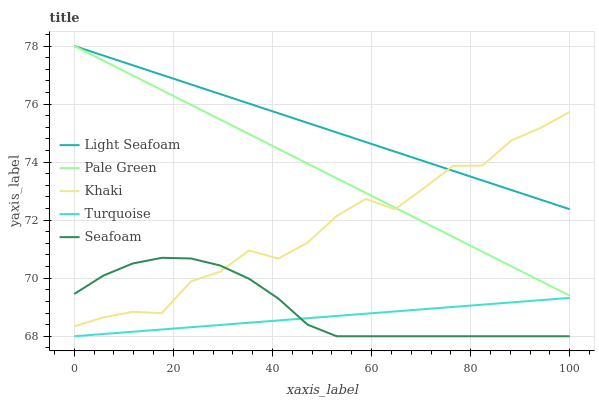Does Turquoise have the minimum area under the curve?
Answer yes or no. Yes. Does Light Seafoam have the maximum area under the curve?
Answer yes or no. Yes. Does Light Seafoam have the minimum area under the curve?
Answer yes or no. No. Does Turquoise have the maximum area under the curve?
Answer yes or no. No. Is Light Seafoam the smoothest?
Answer yes or no. Yes. Is Khaki the roughest?
Answer yes or no. Yes. Is Turquoise the smoothest?
Answer yes or no. No. Is Turquoise the roughest?
Answer yes or no. No. Does Light Seafoam have the lowest value?
Answer yes or no. No. Does Light Seafoam have the highest value?
Answer yes or no. Yes. Does Turquoise have the highest value?
Answer yes or no. No. Is Seafoam less than Light Seafoam?
Answer yes or no. Yes. Is Pale Green greater than Seafoam?
Answer yes or no. Yes. Does Seafoam intersect Light Seafoam?
Answer yes or no. No. 